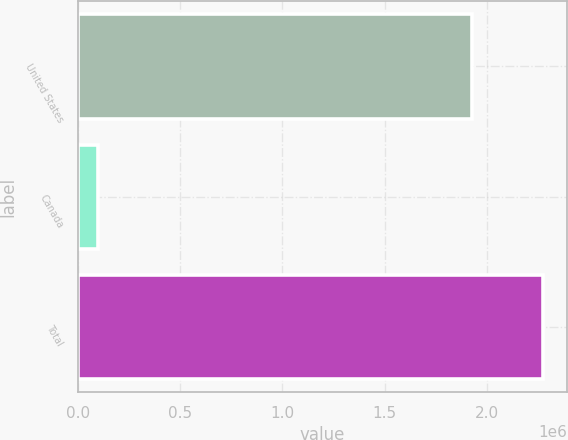Convert chart to OTSL. <chart><loc_0><loc_0><loc_500><loc_500><bar_chart><fcel>United States<fcel>Canada<fcel>Total<nl><fcel>1.92633e+06<fcel>100446<fcel>2.27722e+06<nl></chart> 